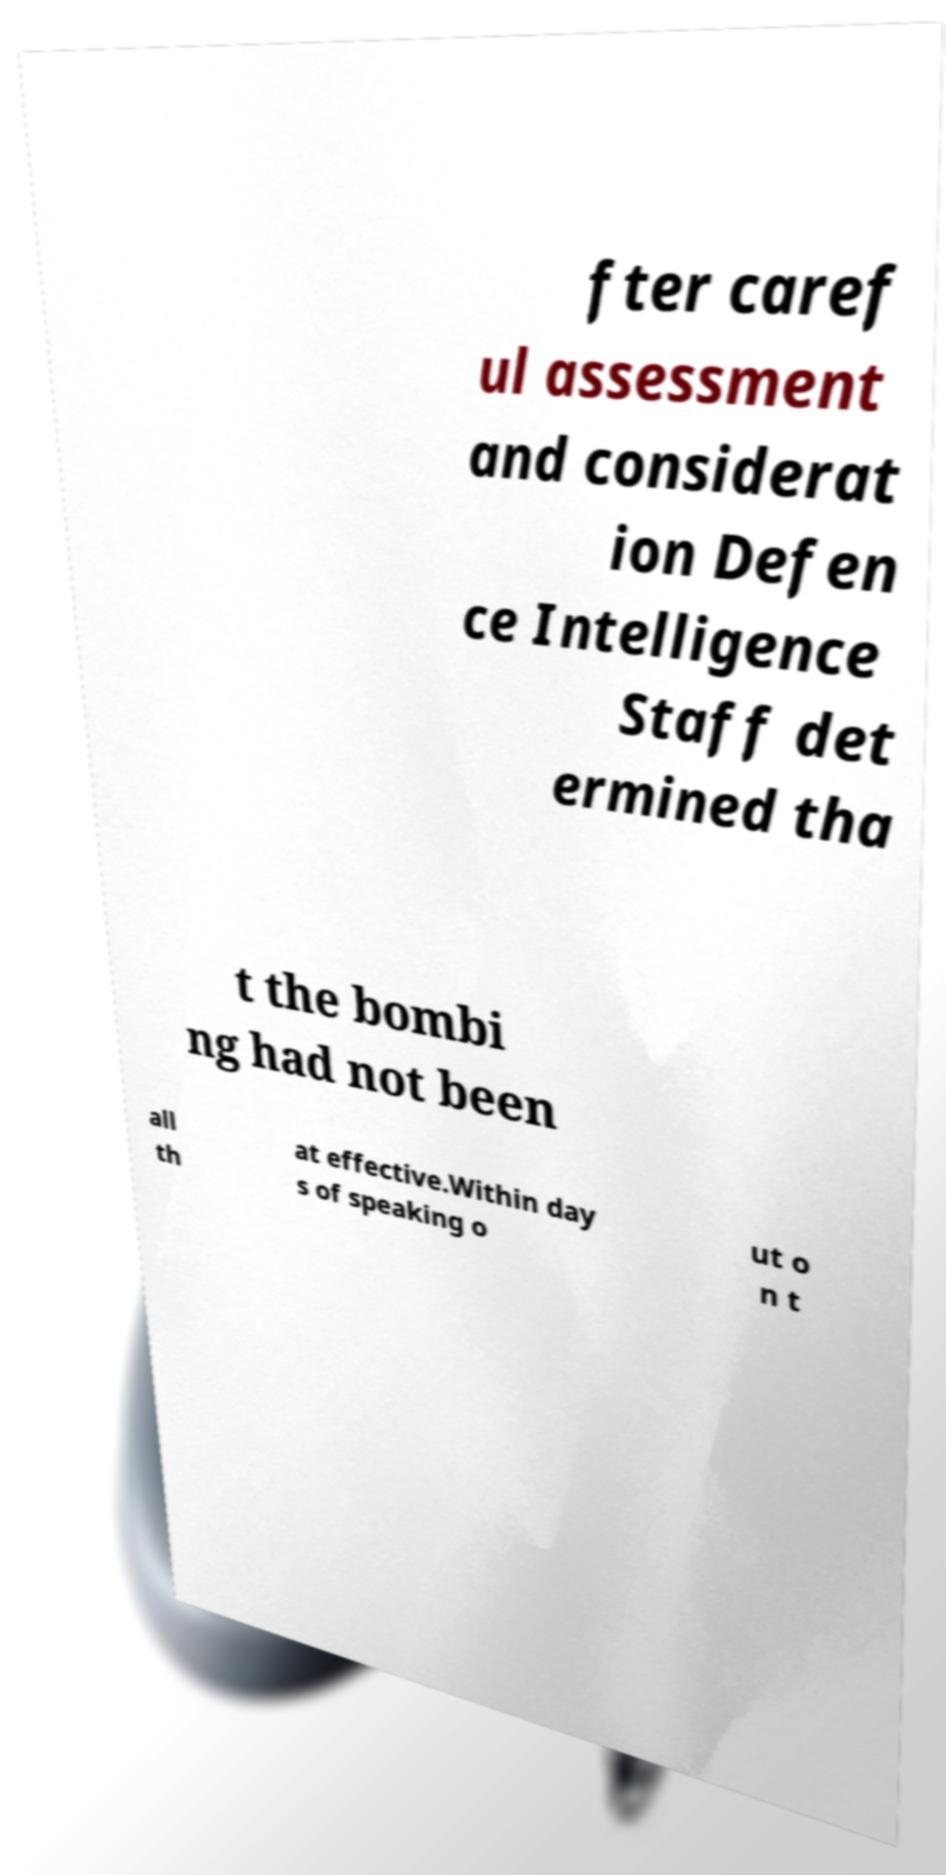Can you accurately transcribe the text from the provided image for me? fter caref ul assessment and considerat ion Defen ce Intelligence Staff det ermined tha t the bombi ng had not been all th at effective.Within day s of speaking o ut o n t 